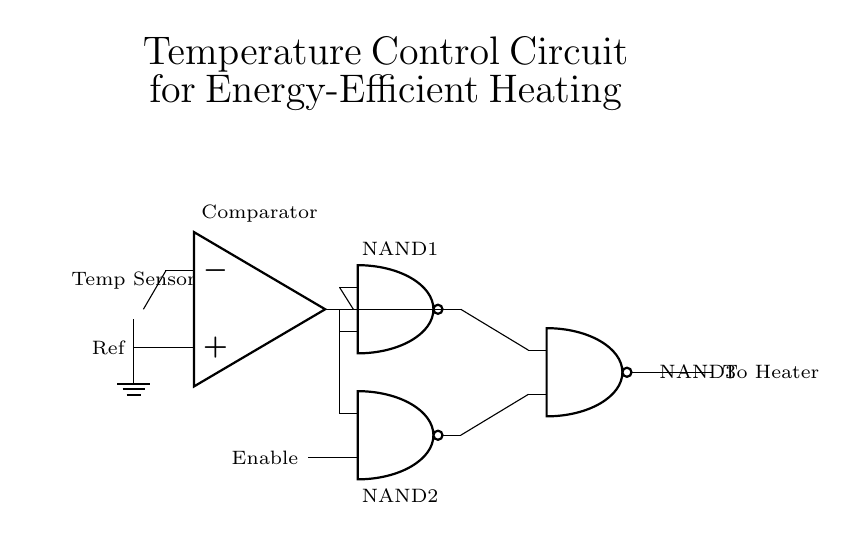What is the main function of this circuit? The circuit is designed for temperature control, specifically to operate a heater efficiently based on the temperature reading.
Answer: Temperature control What component measures temperature? The circuit includes a thermistor, which is a type of temperature sensor that detects changes in temperature.
Answer: Thermistor How many NAND gates are in the circuit? There are three NAND gates illustrated in the schematic, labeled as NAND1, NAND2, and NAND3.
Answer: Three What signal does the comparator produce? The comparator produces an output signal that represents the difference between the input temperature and a reference value, which influences the NAND gates' operation.
Answer: Output signal Which component enables the circuit? The Enable input connected to NAND2 is crucial for controlling whether the heater should be turned on or off based on the logic evaluated by the previous NAND gates.
Answer: Enable How does the output from NAND3 affect the heater? The output from NAND3 directly controls the heater, meaning if NAND3 produces a logic high signal, the heater will activate to provide heating.
Answer: Controls the heater What is the role of the reference input? The reference input provides a fixed temperature threshold against which the thermistor's readings are compared, aiding in determining when to activate the heater.
Answer: Threshold comparison 